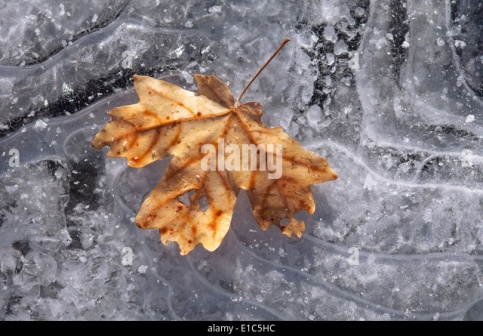What could have happened moments before this image was captured? Just moments before this image was captured, a gentle breeze might have swept through the air, detaching the maple leaf from its branch. Fluttering gracefully, the leaf danced its way down, spinning slightly before settling gently onto the frozen surface. The air was crisp, and the delicate sound of the leaf landing softly on the ice might have been the only noise in the tranquil setting. As the leaf touched the ground, the tiny ice crystals beneath it shimmered briefly, catching the light in a delicate, fleeting sparkle. It was a quiet, solitary moment in the stillness of winter. Imagine a small animal discovering the leaf. What happens next? A curious squirrel emerges from a nearby burrow, its fur fluffed against the cold. Spotting the leaf on the ice, the squirrel approaches it cautiously, sniffing the air around it. With deft movements, it inspects the leaf, its nose twitching in curiosity. Finding nothing of immediate interest, the squirrel scurries off to resume its search for hidden nuts and berries, leaving the leaf undisturbed in its icy rest. 